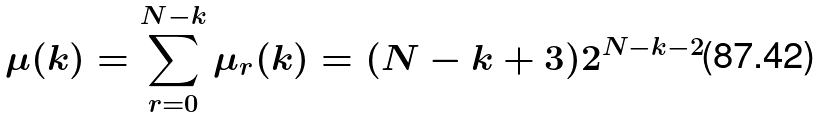<formula> <loc_0><loc_0><loc_500><loc_500>\mu ( k ) = \sum _ { r = 0 } ^ { N - k } \mu _ { r } ( k ) = ( N - k + 3 ) 2 ^ { N - k - 2 }</formula> 